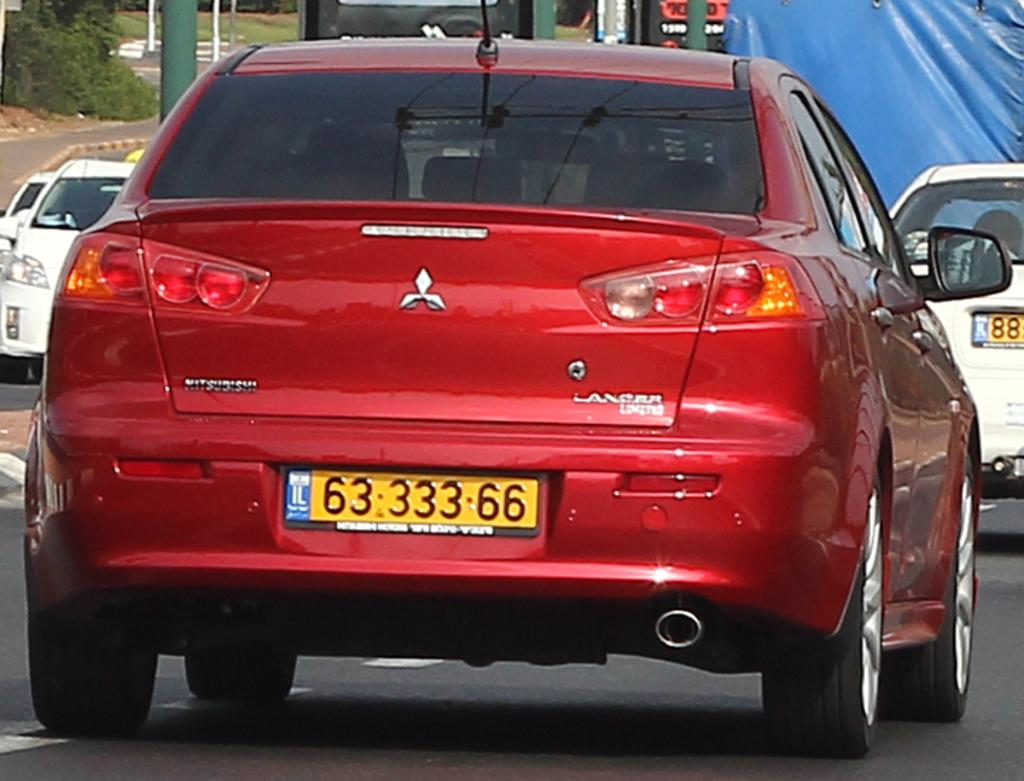<image>
Share a concise interpretation of the image provided. A red Mitsubishi Lancer sedan drives down a road. 